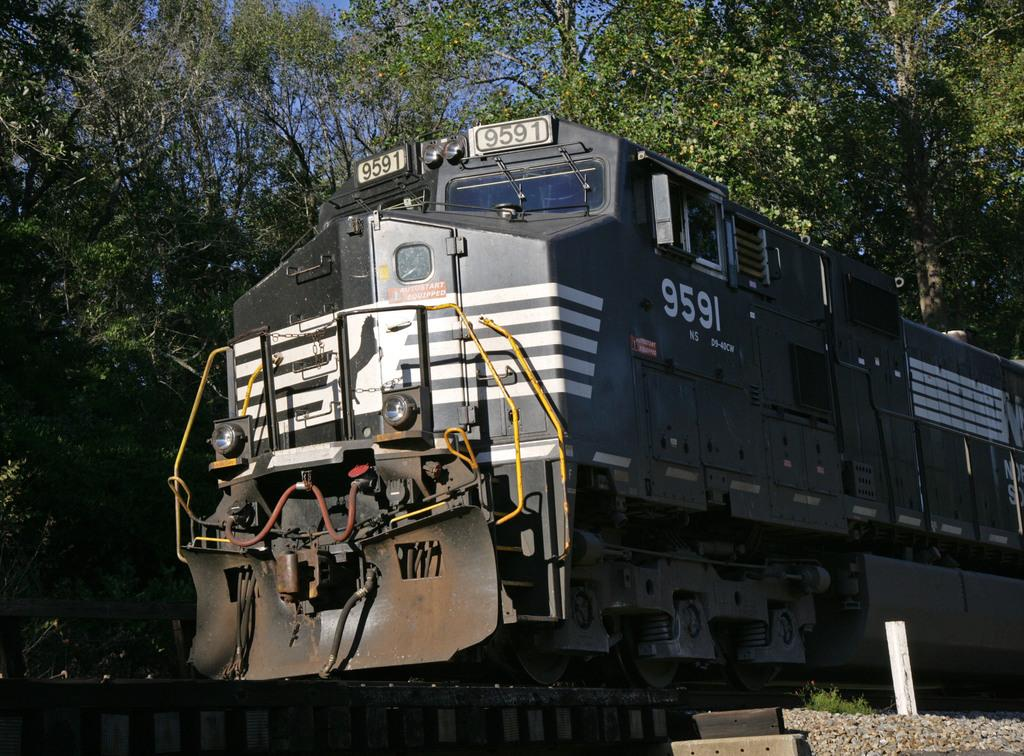What is the main subject of the image? The main subject of the image is a train engine. What is the train engine doing in the image? The train engine is moving on rail tracks. Are there any identifying features on the train engine? Yes, number plates are attached to the train engine. What type of vegetation can be seen in the image? There are trees with branches and leaves in the image. What color is the railway in the image? There is no railway present in the image; it only shows a train engine moving on rail tracks. What day of the week is depicted in the image? The day of the week is not mentioned or depicted in the image. 